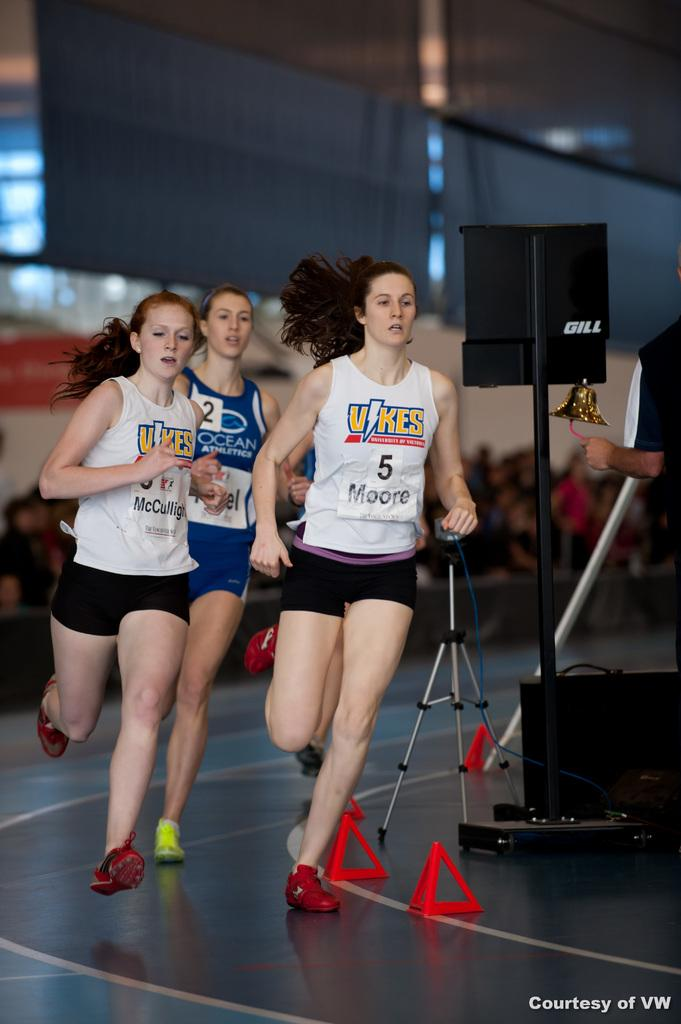<image>
Relay a brief, clear account of the picture shown. A young woman wearing a Ocean Athletics tank top is trailing behind two other young women who are wearing matching Vikes tank tops. 